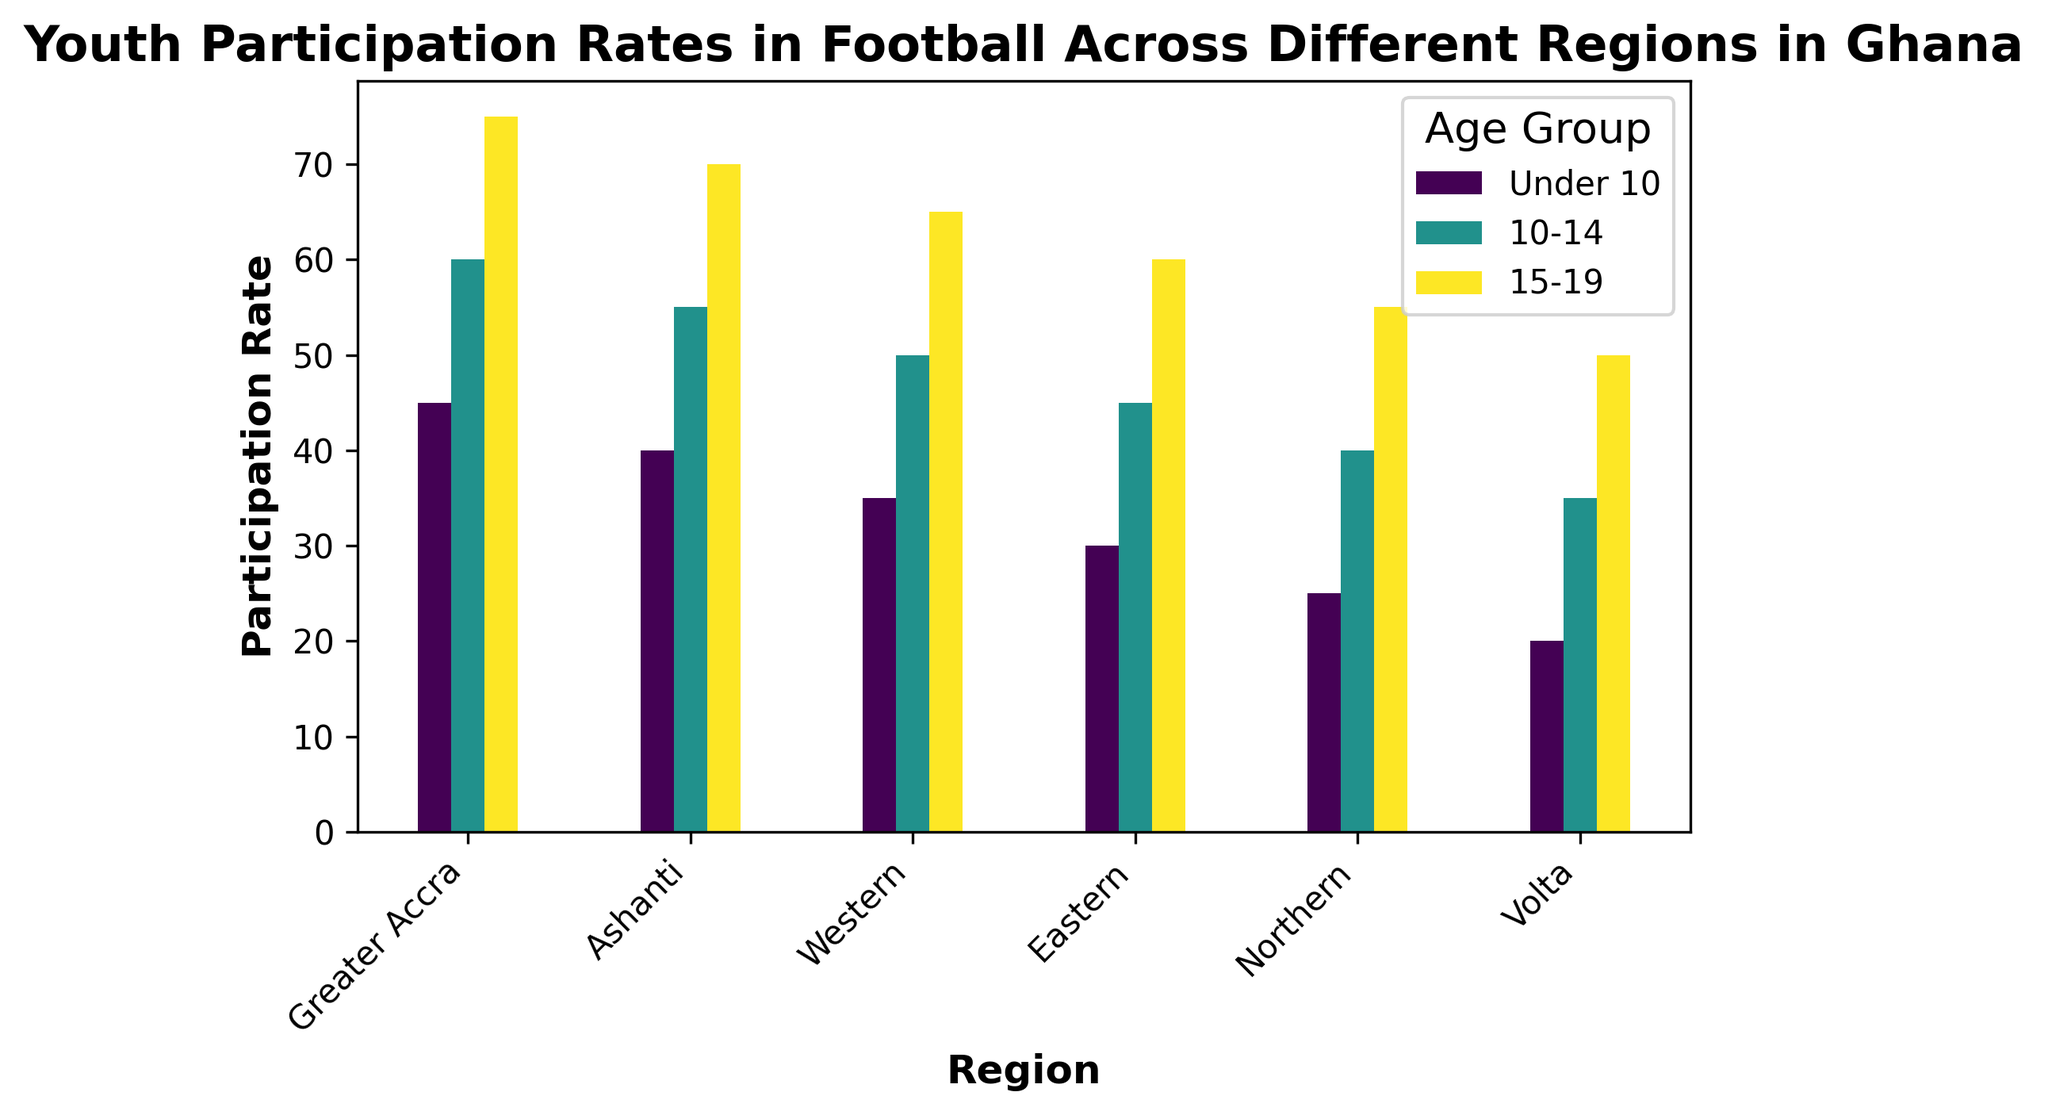What region has the highest participation rate for the 15-19 age group? The bar corresponding to the 15-19 age group in Greater Accra is the tallest, indicating the highest participation rate.
Answer: Greater Accra How does the participation rate for the Under 10 age group in Ashanti compare to that in Greater Accra? The bar for the Under 10 age group in Greater Accra is taller than that in Ashanti, indicating a higher participation rate.
Answer: Greater Accra has a higher participation rate Which age group has the lowest participation rate in Volta? The bar for the Under 10 age group in Volta is the shortest among all age groups, indicating the lowest participation rate.
Answer: Under 10 What is the difference in participation rates between the 10-14 and 15-19 age groups in the Northern region? The participation rate for the 10-14 age group is 40 and for the 15-19 age group is 55. The difference is 55 - 40.
Answer: 15 Calculate the average participation rate for all age groups in the Western region. The participation rates for the Western region are 35 (Under 10), 50 (10-14), and 65 (15-19). The average is (35 + 50 + 65) / 3.
Answer: 50 Which region has the most even distribution of participation rates across all age groups? In Greater Accra, the differences between the heights of the bars for different age groups are smaller compared to other regions, indicating a more even distribution.
Answer: Greater Accra Do the participation rates for the 10-14 age group always fall between the rates for Under 10 and 15-19 age groups across all regions? By visually comparing the bars, we see that in every region (Greater Accra, Ashanti, Western, Eastern, Northern, Volta), the 10-14 age group's participation rate is between the Under 10 and 15-19 age groups.
Answer: Yes If a new region had a 30% participation rate for the 15-19 age group, how would it compare to the existing regions? The lowest participation rate for the 15-19 age group in the existing regions is in Volta with 50%. A new region with 30% would have a significantly lower rate.
Answer: Much lower 